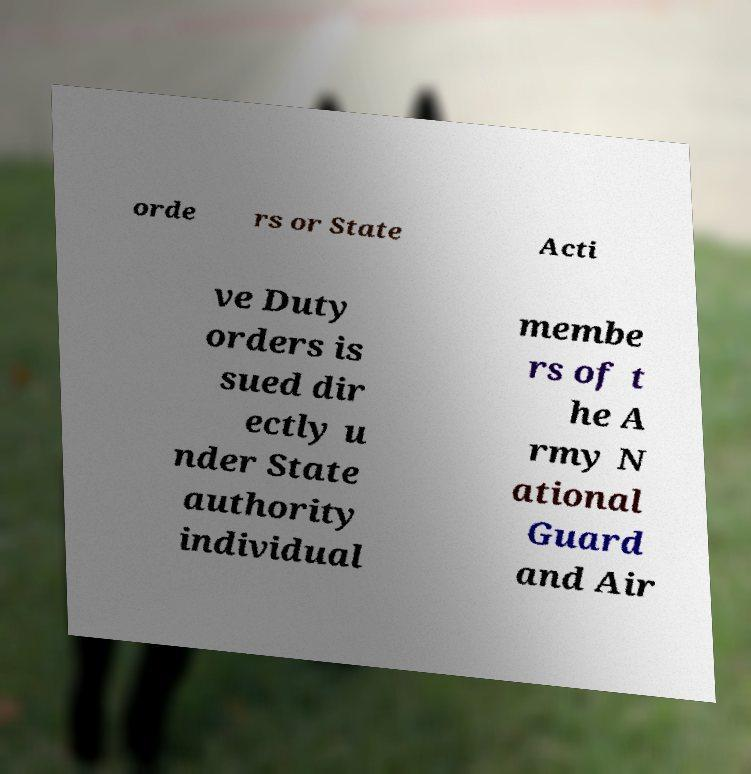Could you assist in decoding the text presented in this image and type it out clearly? orde rs or State Acti ve Duty orders is sued dir ectly u nder State authority individual membe rs of t he A rmy N ational Guard and Air 